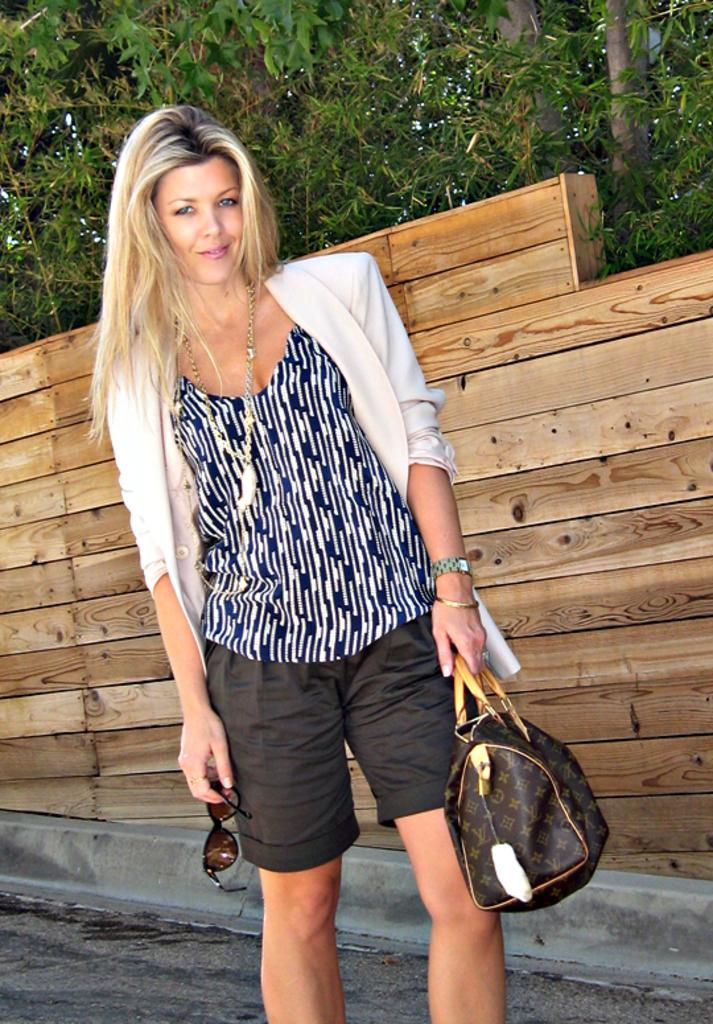Who is the main subject in the image? There is a lady in the center of the image. What is the lady holding in her hands? The lady is holding a bag and sunglasses. What can be seen in the background of the image? There are trees and a wooden fence in the background of the image. What type of curve can be seen in the lady's position in the image? There is no curve in the lady's position in the image; she is standing upright. 